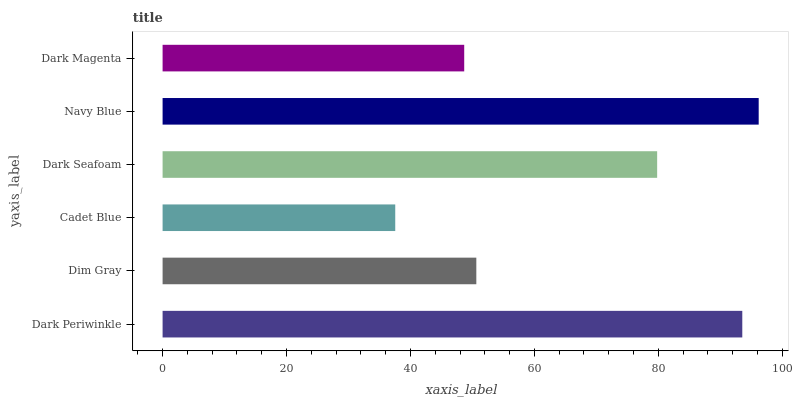Is Cadet Blue the minimum?
Answer yes or no. Yes. Is Navy Blue the maximum?
Answer yes or no. Yes. Is Dim Gray the minimum?
Answer yes or no. No. Is Dim Gray the maximum?
Answer yes or no. No. Is Dark Periwinkle greater than Dim Gray?
Answer yes or no. Yes. Is Dim Gray less than Dark Periwinkle?
Answer yes or no. Yes. Is Dim Gray greater than Dark Periwinkle?
Answer yes or no. No. Is Dark Periwinkle less than Dim Gray?
Answer yes or no. No. Is Dark Seafoam the high median?
Answer yes or no. Yes. Is Dim Gray the low median?
Answer yes or no. Yes. Is Navy Blue the high median?
Answer yes or no. No. Is Navy Blue the low median?
Answer yes or no. No. 